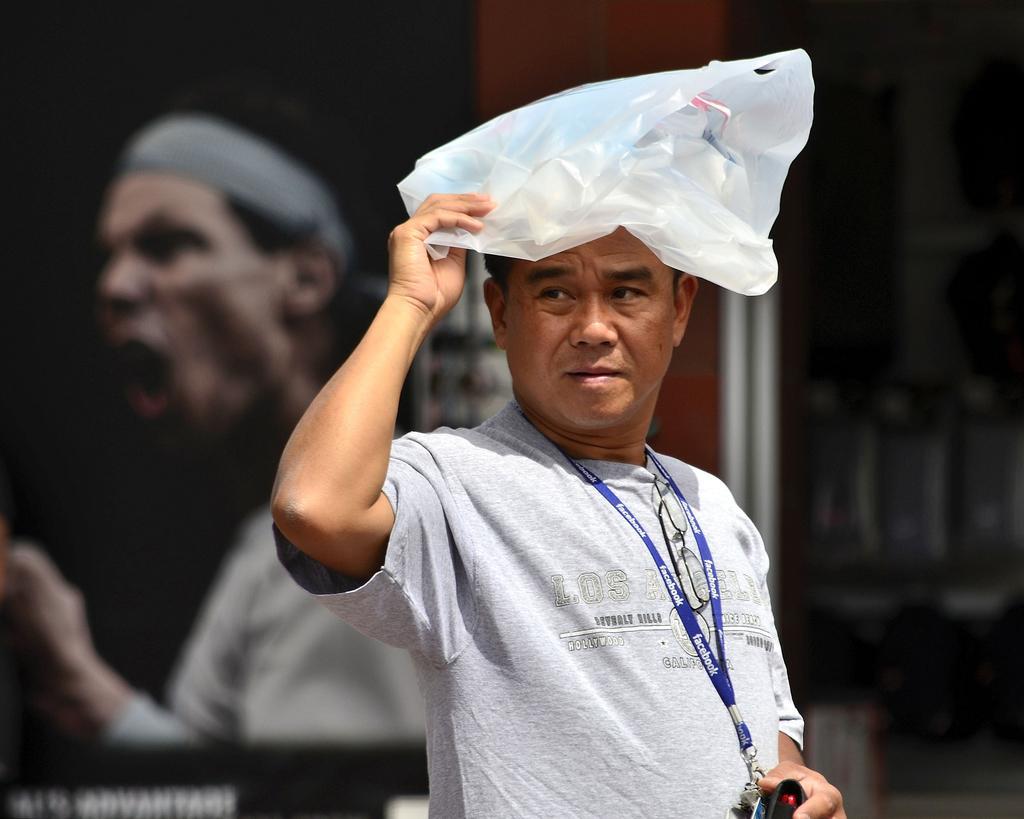Describe this image in one or two sentences. In the foreground of this picture we can see a person wearing t-shirt, holding some objects and seems to be standing. In the background we can see the depiction of a person and the text on the poster and we can see some other objects. 